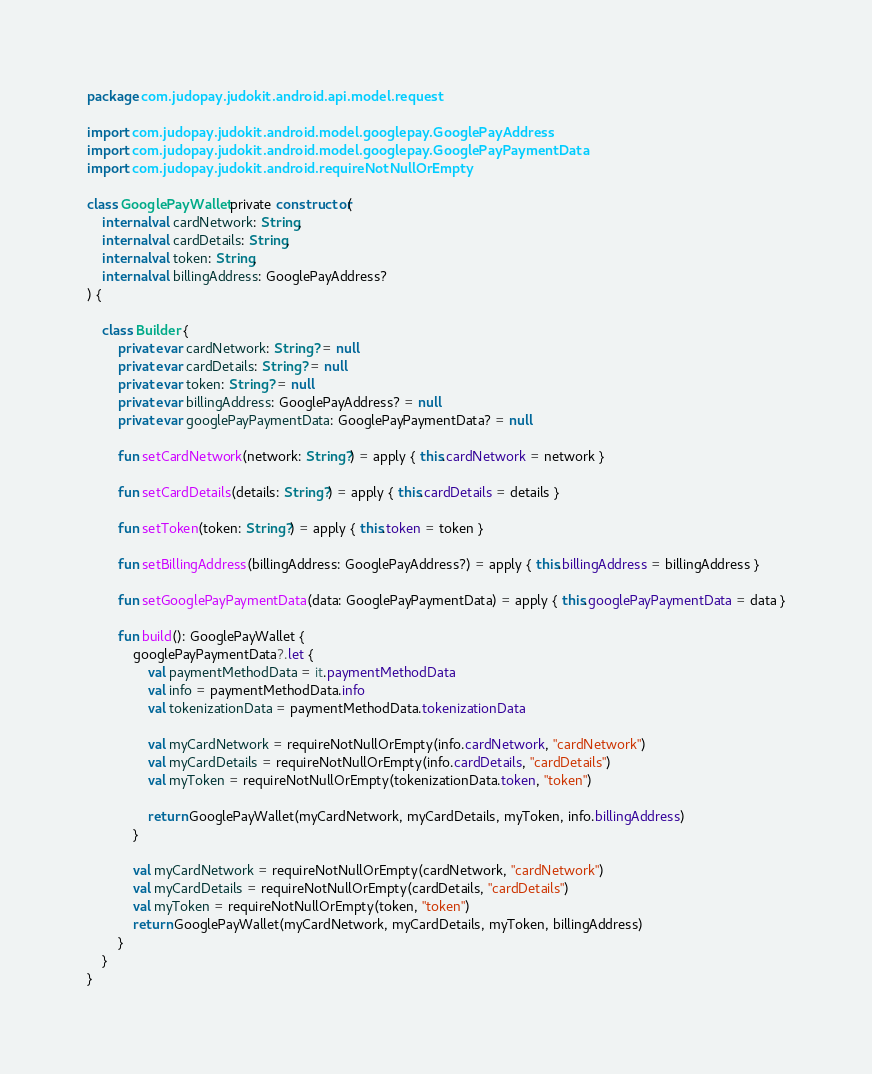Convert code to text. <code><loc_0><loc_0><loc_500><loc_500><_Kotlin_>package com.judopay.judokit.android.api.model.request

import com.judopay.judokit.android.model.googlepay.GooglePayAddress
import com.judopay.judokit.android.model.googlepay.GooglePayPaymentData
import com.judopay.judokit.android.requireNotNullOrEmpty

class GooglePayWallet private constructor(
    internal val cardNetwork: String,
    internal val cardDetails: String,
    internal val token: String,
    internal val billingAddress: GooglePayAddress?
) {

    class Builder {
        private var cardNetwork: String? = null
        private var cardDetails: String? = null
        private var token: String? = null
        private var billingAddress: GooglePayAddress? = null
        private var googlePayPaymentData: GooglePayPaymentData? = null

        fun setCardNetwork(network: String?) = apply { this.cardNetwork = network }

        fun setCardDetails(details: String?) = apply { this.cardDetails = details }

        fun setToken(token: String?) = apply { this.token = token }

        fun setBillingAddress(billingAddress: GooglePayAddress?) = apply { this.billingAddress = billingAddress }

        fun setGooglePayPaymentData(data: GooglePayPaymentData) = apply { this.googlePayPaymentData = data }

        fun build(): GooglePayWallet {
            googlePayPaymentData?.let {
                val paymentMethodData = it.paymentMethodData
                val info = paymentMethodData.info
                val tokenizationData = paymentMethodData.tokenizationData

                val myCardNetwork = requireNotNullOrEmpty(info.cardNetwork, "cardNetwork")
                val myCardDetails = requireNotNullOrEmpty(info.cardDetails, "cardDetails")
                val myToken = requireNotNullOrEmpty(tokenizationData.token, "token")

                return GooglePayWallet(myCardNetwork, myCardDetails, myToken, info.billingAddress)
            }

            val myCardNetwork = requireNotNullOrEmpty(cardNetwork, "cardNetwork")
            val myCardDetails = requireNotNullOrEmpty(cardDetails, "cardDetails")
            val myToken = requireNotNullOrEmpty(token, "token")
            return GooglePayWallet(myCardNetwork, myCardDetails, myToken, billingAddress)
        }
    }
}
</code> 